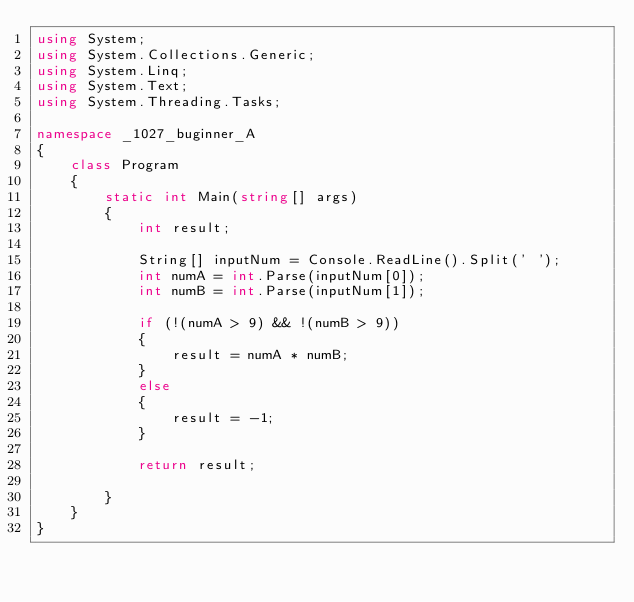Convert code to text. <code><loc_0><loc_0><loc_500><loc_500><_C#_>using System;
using System.Collections.Generic;
using System.Linq;
using System.Text;
using System.Threading.Tasks;

namespace _1027_buginner_A
{
    class Program
    {
        static int Main(string[] args)
        {
            int result;

            String[] inputNum = Console.ReadLine().Split(' ');
            int numA = int.Parse(inputNum[0]);
            int numB = int.Parse(inputNum[1]);

            if (!(numA > 9) && !(numB > 9))
            {
                result = numA * numB;
            }
            else
            {
                result = -1;
            }

            return result;

        }
    }
}
</code> 